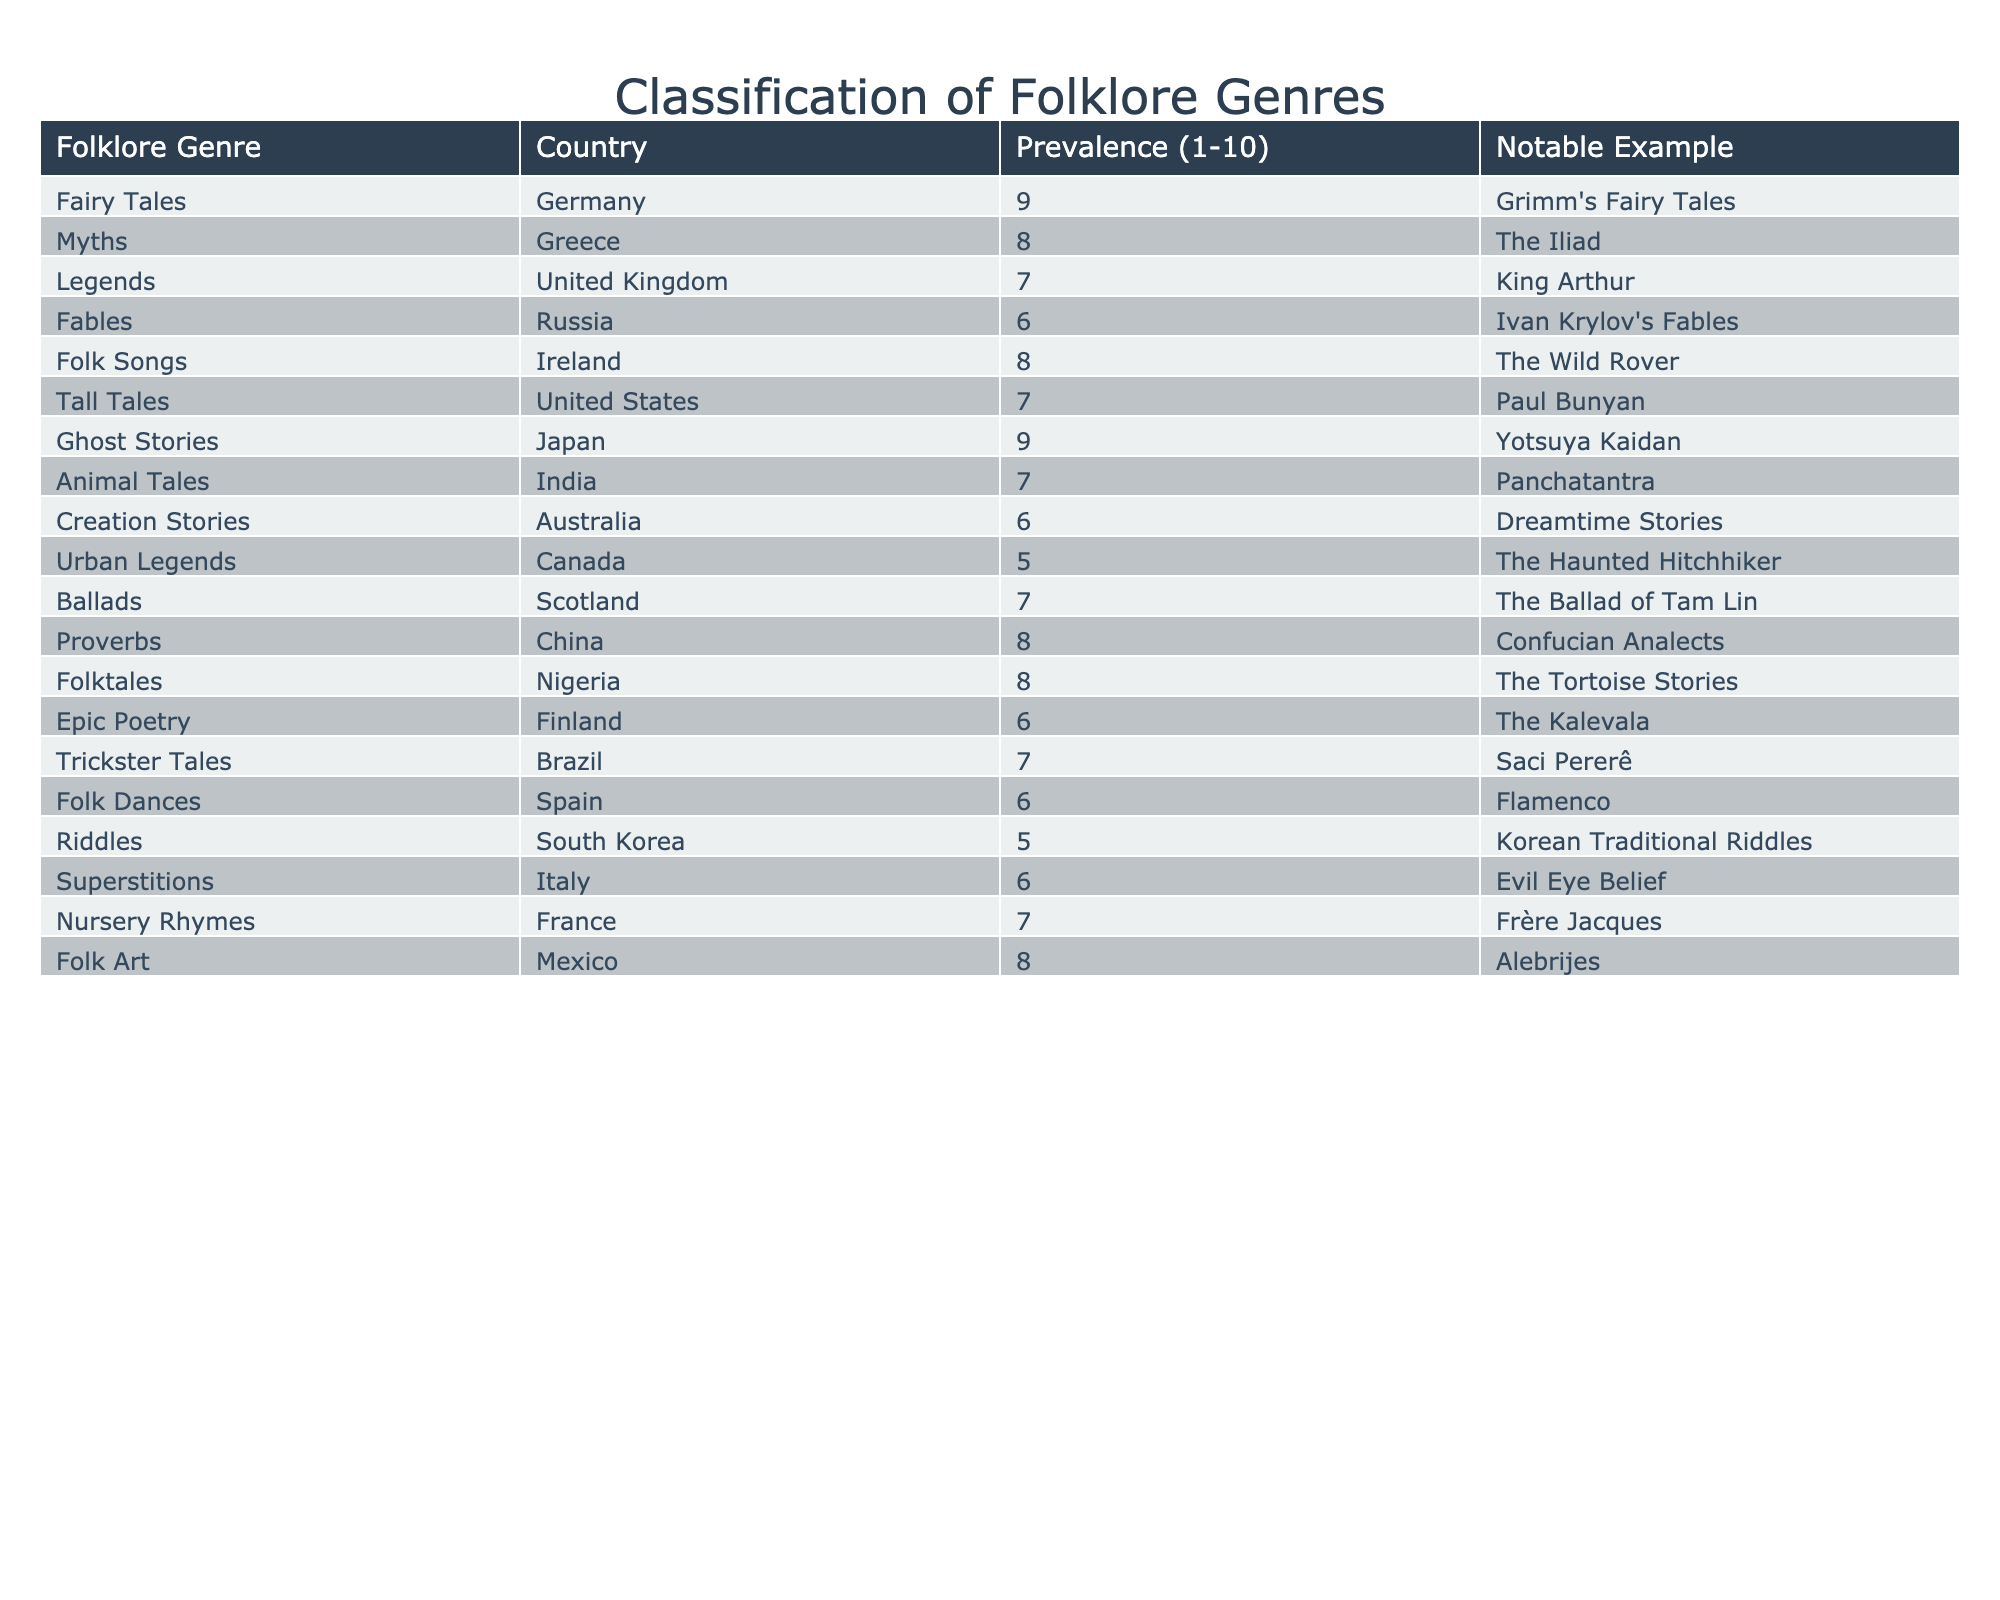What's the most prevalent folklore genre in Germany? The table shows that the prevalence of Fairy Tales in Germany is 9, which is the highest value in the table.
Answer: Fairy Tales Which country has the highest prevalence of Ghost Stories? The table indicates that Japan has a prevalence score of 9 for Ghost Stories, the highest compared to other countries listed.
Answer: Japan How many genres have a prevalence rating of 6? From the table, there are four genres—in Russia (Fables), Australia (Creation Stories), Spain (Folk Dances), and Italy (Superstitions)—that have a prevalence rating of 6.
Answer: 4 What is the notable example of folklore from Russia? According to the table, Ivan Krylov's Fables is the notable example of folklore from Russia.
Answer: Ivan Krylov's Fables Is there a genre that both Mexico and China have a prevalence of 8? The table lists that Mexico has Folk Art with a prevalence of 8 and China has Proverbs with a prevalence of 8. However, they do not have the same genre; hence, the answer is no.
Answer: No What is the average prevalence of the genres listed in the table? The prevalence scores are: 9, 8, 7, 6, 8, 7, 9, 7, 6, 5, 7, 8, 8, 6, 7, 6, 5, 6, and 7. The sum is 115, and with 18 genres, the average is 115/18, which equals approximately 6.39.
Answer: 6.39 Which folklore genre is the least prevalent and in which country? The least prevalent genre is Urban Legends in Canada, which has a prevalence rating of 5.
Answer: Urban Legends, Canada Can you identify two countries that share the same folklore genre with a prevalence of 7? The table shows that the United States (Tall Tales) and Scotland (Ballads) both have a folklore genre with a prevalence of 7.
Answer: United States, Scotland What notable example represents Animal Tales from India? The notable example for Animal Tales from India is the Panchatantra, as indicated in the table.
Answer: Panchatantra Which country has a higher prevalence for Folk Songs, Ireland or the United Kingdom? According to the table, Ireland has a prevalence rating of 8 for Folk Songs, while the United Kingdom has a prevalence of 7 for Legends. Hence, Ireland is higher.
Answer: Ireland How does the prevalence of Myths in Greece compare to that of Tall Tales in the United States? The table indicates Myths in Greece has a prevalence of 8, while Tall Tales in the United States has a prevalence of 7. Comparatively, Myths are more prevalent than Tall Tales.
Answer: Myths are more prevalent 